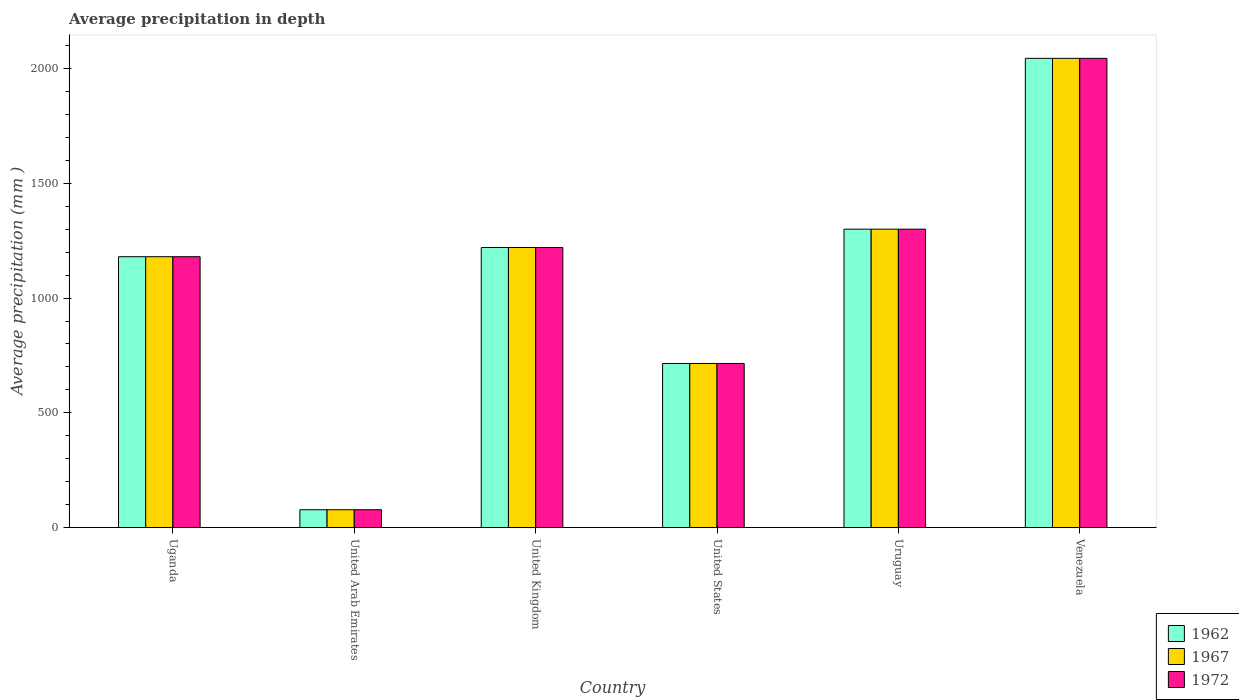How many different coloured bars are there?
Provide a succinct answer. 3. How many groups of bars are there?
Ensure brevity in your answer.  6. Are the number of bars per tick equal to the number of legend labels?
Make the answer very short. Yes. How many bars are there on the 3rd tick from the right?
Offer a terse response. 3. What is the label of the 6th group of bars from the left?
Offer a terse response. Venezuela. What is the average precipitation in 1972 in Venezuela?
Your answer should be very brief. 2044. Across all countries, what is the maximum average precipitation in 1972?
Provide a succinct answer. 2044. In which country was the average precipitation in 1962 maximum?
Your response must be concise. Venezuela. In which country was the average precipitation in 1962 minimum?
Your answer should be very brief. United Arab Emirates. What is the total average precipitation in 1972 in the graph?
Your answer should be compact. 6537. What is the difference between the average precipitation in 1967 in Uganda and that in Venezuela?
Provide a short and direct response. -864. What is the average average precipitation in 1962 per country?
Offer a terse response. 1089.5. What is the difference between the average precipitation of/in 1962 and average precipitation of/in 1967 in Uganda?
Offer a terse response. 0. What is the ratio of the average precipitation in 1972 in United Kingdom to that in United States?
Provide a succinct answer. 1.71. What is the difference between the highest and the second highest average precipitation in 1962?
Ensure brevity in your answer.  -824. What is the difference between the highest and the lowest average precipitation in 1967?
Your response must be concise. 1966. In how many countries, is the average precipitation in 1972 greater than the average average precipitation in 1972 taken over all countries?
Give a very brief answer. 4. Is the sum of the average precipitation in 1972 in United Kingdom and Uruguay greater than the maximum average precipitation in 1967 across all countries?
Your response must be concise. Yes. What does the 2nd bar from the left in Venezuela represents?
Your response must be concise. 1967. What does the 3rd bar from the right in United States represents?
Your answer should be compact. 1962. Are all the bars in the graph horizontal?
Keep it short and to the point. No. How many countries are there in the graph?
Make the answer very short. 6. What is the difference between two consecutive major ticks on the Y-axis?
Keep it short and to the point. 500. Are the values on the major ticks of Y-axis written in scientific E-notation?
Offer a very short reply. No. Does the graph contain grids?
Keep it short and to the point. No. Where does the legend appear in the graph?
Your answer should be compact. Bottom right. How many legend labels are there?
Keep it short and to the point. 3. How are the legend labels stacked?
Keep it short and to the point. Vertical. What is the title of the graph?
Provide a short and direct response. Average precipitation in depth. What is the label or title of the X-axis?
Keep it short and to the point. Country. What is the label or title of the Y-axis?
Keep it short and to the point. Average precipitation (mm ). What is the Average precipitation (mm ) of 1962 in Uganda?
Give a very brief answer. 1180. What is the Average precipitation (mm ) of 1967 in Uganda?
Make the answer very short. 1180. What is the Average precipitation (mm ) of 1972 in Uganda?
Ensure brevity in your answer.  1180. What is the Average precipitation (mm ) of 1962 in United Kingdom?
Give a very brief answer. 1220. What is the Average precipitation (mm ) in 1967 in United Kingdom?
Offer a very short reply. 1220. What is the Average precipitation (mm ) of 1972 in United Kingdom?
Give a very brief answer. 1220. What is the Average precipitation (mm ) in 1962 in United States?
Make the answer very short. 715. What is the Average precipitation (mm ) of 1967 in United States?
Give a very brief answer. 715. What is the Average precipitation (mm ) of 1972 in United States?
Keep it short and to the point. 715. What is the Average precipitation (mm ) in 1962 in Uruguay?
Offer a very short reply. 1300. What is the Average precipitation (mm ) in 1967 in Uruguay?
Make the answer very short. 1300. What is the Average precipitation (mm ) of 1972 in Uruguay?
Provide a short and direct response. 1300. What is the Average precipitation (mm ) in 1962 in Venezuela?
Provide a succinct answer. 2044. What is the Average precipitation (mm ) of 1967 in Venezuela?
Your response must be concise. 2044. What is the Average precipitation (mm ) in 1972 in Venezuela?
Ensure brevity in your answer.  2044. Across all countries, what is the maximum Average precipitation (mm ) of 1962?
Your answer should be very brief. 2044. Across all countries, what is the maximum Average precipitation (mm ) in 1967?
Your answer should be compact. 2044. Across all countries, what is the maximum Average precipitation (mm ) in 1972?
Offer a terse response. 2044. Across all countries, what is the minimum Average precipitation (mm ) of 1972?
Keep it short and to the point. 78. What is the total Average precipitation (mm ) of 1962 in the graph?
Ensure brevity in your answer.  6537. What is the total Average precipitation (mm ) in 1967 in the graph?
Provide a short and direct response. 6537. What is the total Average precipitation (mm ) in 1972 in the graph?
Your response must be concise. 6537. What is the difference between the Average precipitation (mm ) in 1962 in Uganda and that in United Arab Emirates?
Keep it short and to the point. 1102. What is the difference between the Average precipitation (mm ) in 1967 in Uganda and that in United Arab Emirates?
Your answer should be compact. 1102. What is the difference between the Average precipitation (mm ) of 1972 in Uganda and that in United Arab Emirates?
Keep it short and to the point. 1102. What is the difference between the Average precipitation (mm ) of 1972 in Uganda and that in United Kingdom?
Ensure brevity in your answer.  -40. What is the difference between the Average precipitation (mm ) in 1962 in Uganda and that in United States?
Your response must be concise. 465. What is the difference between the Average precipitation (mm ) in 1967 in Uganda and that in United States?
Offer a terse response. 465. What is the difference between the Average precipitation (mm ) of 1972 in Uganda and that in United States?
Make the answer very short. 465. What is the difference between the Average precipitation (mm ) in 1962 in Uganda and that in Uruguay?
Give a very brief answer. -120. What is the difference between the Average precipitation (mm ) in 1967 in Uganda and that in Uruguay?
Offer a very short reply. -120. What is the difference between the Average precipitation (mm ) of 1972 in Uganda and that in Uruguay?
Ensure brevity in your answer.  -120. What is the difference between the Average precipitation (mm ) of 1962 in Uganda and that in Venezuela?
Your answer should be compact. -864. What is the difference between the Average precipitation (mm ) of 1967 in Uganda and that in Venezuela?
Your response must be concise. -864. What is the difference between the Average precipitation (mm ) of 1972 in Uganda and that in Venezuela?
Make the answer very short. -864. What is the difference between the Average precipitation (mm ) in 1962 in United Arab Emirates and that in United Kingdom?
Offer a very short reply. -1142. What is the difference between the Average precipitation (mm ) of 1967 in United Arab Emirates and that in United Kingdom?
Provide a short and direct response. -1142. What is the difference between the Average precipitation (mm ) of 1972 in United Arab Emirates and that in United Kingdom?
Your answer should be compact. -1142. What is the difference between the Average precipitation (mm ) in 1962 in United Arab Emirates and that in United States?
Make the answer very short. -637. What is the difference between the Average precipitation (mm ) of 1967 in United Arab Emirates and that in United States?
Make the answer very short. -637. What is the difference between the Average precipitation (mm ) in 1972 in United Arab Emirates and that in United States?
Offer a very short reply. -637. What is the difference between the Average precipitation (mm ) in 1962 in United Arab Emirates and that in Uruguay?
Offer a terse response. -1222. What is the difference between the Average precipitation (mm ) of 1967 in United Arab Emirates and that in Uruguay?
Your answer should be compact. -1222. What is the difference between the Average precipitation (mm ) of 1972 in United Arab Emirates and that in Uruguay?
Offer a very short reply. -1222. What is the difference between the Average precipitation (mm ) of 1962 in United Arab Emirates and that in Venezuela?
Provide a succinct answer. -1966. What is the difference between the Average precipitation (mm ) in 1967 in United Arab Emirates and that in Venezuela?
Ensure brevity in your answer.  -1966. What is the difference between the Average precipitation (mm ) in 1972 in United Arab Emirates and that in Venezuela?
Your response must be concise. -1966. What is the difference between the Average precipitation (mm ) in 1962 in United Kingdom and that in United States?
Offer a very short reply. 505. What is the difference between the Average precipitation (mm ) of 1967 in United Kingdom and that in United States?
Give a very brief answer. 505. What is the difference between the Average precipitation (mm ) in 1972 in United Kingdom and that in United States?
Provide a succinct answer. 505. What is the difference between the Average precipitation (mm ) in 1962 in United Kingdom and that in Uruguay?
Make the answer very short. -80. What is the difference between the Average precipitation (mm ) of 1967 in United Kingdom and that in Uruguay?
Keep it short and to the point. -80. What is the difference between the Average precipitation (mm ) in 1972 in United Kingdom and that in Uruguay?
Keep it short and to the point. -80. What is the difference between the Average precipitation (mm ) of 1962 in United Kingdom and that in Venezuela?
Make the answer very short. -824. What is the difference between the Average precipitation (mm ) of 1967 in United Kingdom and that in Venezuela?
Ensure brevity in your answer.  -824. What is the difference between the Average precipitation (mm ) of 1972 in United Kingdom and that in Venezuela?
Offer a very short reply. -824. What is the difference between the Average precipitation (mm ) in 1962 in United States and that in Uruguay?
Give a very brief answer. -585. What is the difference between the Average precipitation (mm ) of 1967 in United States and that in Uruguay?
Offer a terse response. -585. What is the difference between the Average precipitation (mm ) of 1972 in United States and that in Uruguay?
Provide a succinct answer. -585. What is the difference between the Average precipitation (mm ) in 1962 in United States and that in Venezuela?
Your answer should be compact. -1329. What is the difference between the Average precipitation (mm ) in 1967 in United States and that in Venezuela?
Ensure brevity in your answer.  -1329. What is the difference between the Average precipitation (mm ) in 1972 in United States and that in Venezuela?
Give a very brief answer. -1329. What is the difference between the Average precipitation (mm ) in 1962 in Uruguay and that in Venezuela?
Provide a succinct answer. -744. What is the difference between the Average precipitation (mm ) of 1967 in Uruguay and that in Venezuela?
Make the answer very short. -744. What is the difference between the Average precipitation (mm ) of 1972 in Uruguay and that in Venezuela?
Ensure brevity in your answer.  -744. What is the difference between the Average precipitation (mm ) in 1962 in Uganda and the Average precipitation (mm ) in 1967 in United Arab Emirates?
Give a very brief answer. 1102. What is the difference between the Average precipitation (mm ) in 1962 in Uganda and the Average precipitation (mm ) in 1972 in United Arab Emirates?
Ensure brevity in your answer.  1102. What is the difference between the Average precipitation (mm ) in 1967 in Uganda and the Average precipitation (mm ) in 1972 in United Arab Emirates?
Offer a terse response. 1102. What is the difference between the Average precipitation (mm ) in 1962 in Uganda and the Average precipitation (mm ) in 1967 in United Kingdom?
Ensure brevity in your answer.  -40. What is the difference between the Average precipitation (mm ) of 1962 in Uganda and the Average precipitation (mm ) of 1967 in United States?
Your answer should be very brief. 465. What is the difference between the Average precipitation (mm ) of 1962 in Uganda and the Average precipitation (mm ) of 1972 in United States?
Ensure brevity in your answer.  465. What is the difference between the Average precipitation (mm ) in 1967 in Uganda and the Average precipitation (mm ) in 1972 in United States?
Offer a very short reply. 465. What is the difference between the Average precipitation (mm ) in 1962 in Uganda and the Average precipitation (mm ) in 1967 in Uruguay?
Your response must be concise. -120. What is the difference between the Average precipitation (mm ) of 1962 in Uganda and the Average precipitation (mm ) of 1972 in Uruguay?
Offer a terse response. -120. What is the difference between the Average precipitation (mm ) of 1967 in Uganda and the Average precipitation (mm ) of 1972 in Uruguay?
Your answer should be very brief. -120. What is the difference between the Average precipitation (mm ) of 1962 in Uganda and the Average precipitation (mm ) of 1967 in Venezuela?
Give a very brief answer. -864. What is the difference between the Average precipitation (mm ) in 1962 in Uganda and the Average precipitation (mm ) in 1972 in Venezuela?
Keep it short and to the point. -864. What is the difference between the Average precipitation (mm ) of 1967 in Uganda and the Average precipitation (mm ) of 1972 in Venezuela?
Provide a succinct answer. -864. What is the difference between the Average precipitation (mm ) in 1962 in United Arab Emirates and the Average precipitation (mm ) in 1967 in United Kingdom?
Your response must be concise. -1142. What is the difference between the Average precipitation (mm ) of 1962 in United Arab Emirates and the Average precipitation (mm ) of 1972 in United Kingdom?
Offer a very short reply. -1142. What is the difference between the Average precipitation (mm ) of 1967 in United Arab Emirates and the Average precipitation (mm ) of 1972 in United Kingdom?
Keep it short and to the point. -1142. What is the difference between the Average precipitation (mm ) of 1962 in United Arab Emirates and the Average precipitation (mm ) of 1967 in United States?
Your answer should be compact. -637. What is the difference between the Average precipitation (mm ) in 1962 in United Arab Emirates and the Average precipitation (mm ) in 1972 in United States?
Make the answer very short. -637. What is the difference between the Average precipitation (mm ) in 1967 in United Arab Emirates and the Average precipitation (mm ) in 1972 in United States?
Offer a very short reply. -637. What is the difference between the Average precipitation (mm ) in 1962 in United Arab Emirates and the Average precipitation (mm ) in 1967 in Uruguay?
Offer a terse response. -1222. What is the difference between the Average precipitation (mm ) in 1962 in United Arab Emirates and the Average precipitation (mm ) in 1972 in Uruguay?
Provide a succinct answer. -1222. What is the difference between the Average precipitation (mm ) of 1967 in United Arab Emirates and the Average precipitation (mm ) of 1972 in Uruguay?
Keep it short and to the point. -1222. What is the difference between the Average precipitation (mm ) of 1962 in United Arab Emirates and the Average precipitation (mm ) of 1967 in Venezuela?
Give a very brief answer. -1966. What is the difference between the Average precipitation (mm ) of 1962 in United Arab Emirates and the Average precipitation (mm ) of 1972 in Venezuela?
Your response must be concise. -1966. What is the difference between the Average precipitation (mm ) in 1967 in United Arab Emirates and the Average precipitation (mm ) in 1972 in Venezuela?
Give a very brief answer. -1966. What is the difference between the Average precipitation (mm ) of 1962 in United Kingdom and the Average precipitation (mm ) of 1967 in United States?
Your response must be concise. 505. What is the difference between the Average precipitation (mm ) of 1962 in United Kingdom and the Average precipitation (mm ) of 1972 in United States?
Your answer should be very brief. 505. What is the difference between the Average precipitation (mm ) of 1967 in United Kingdom and the Average precipitation (mm ) of 1972 in United States?
Your answer should be compact. 505. What is the difference between the Average precipitation (mm ) of 1962 in United Kingdom and the Average precipitation (mm ) of 1967 in Uruguay?
Make the answer very short. -80. What is the difference between the Average precipitation (mm ) in 1962 in United Kingdom and the Average precipitation (mm ) in 1972 in Uruguay?
Make the answer very short. -80. What is the difference between the Average precipitation (mm ) in 1967 in United Kingdom and the Average precipitation (mm ) in 1972 in Uruguay?
Keep it short and to the point. -80. What is the difference between the Average precipitation (mm ) in 1962 in United Kingdom and the Average precipitation (mm ) in 1967 in Venezuela?
Your answer should be compact. -824. What is the difference between the Average precipitation (mm ) in 1962 in United Kingdom and the Average precipitation (mm ) in 1972 in Venezuela?
Offer a terse response. -824. What is the difference between the Average precipitation (mm ) of 1967 in United Kingdom and the Average precipitation (mm ) of 1972 in Venezuela?
Your answer should be very brief. -824. What is the difference between the Average precipitation (mm ) in 1962 in United States and the Average precipitation (mm ) in 1967 in Uruguay?
Give a very brief answer. -585. What is the difference between the Average precipitation (mm ) of 1962 in United States and the Average precipitation (mm ) of 1972 in Uruguay?
Provide a short and direct response. -585. What is the difference between the Average precipitation (mm ) of 1967 in United States and the Average precipitation (mm ) of 1972 in Uruguay?
Give a very brief answer. -585. What is the difference between the Average precipitation (mm ) of 1962 in United States and the Average precipitation (mm ) of 1967 in Venezuela?
Give a very brief answer. -1329. What is the difference between the Average precipitation (mm ) in 1962 in United States and the Average precipitation (mm ) in 1972 in Venezuela?
Offer a terse response. -1329. What is the difference between the Average precipitation (mm ) in 1967 in United States and the Average precipitation (mm ) in 1972 in Venezuela?
Offer a very short reply. -1329. What is the difference between the Average precipitation (mm ) of 1962 in Uruguay and the Average precipitation (mm ) of 1967 in Venezuela?
Offer a very short reply. -744. What is the difference between the Average precipitation (mm ) of 1962 in Uruguay and the Average precipitation (mm ) of 1972 in Venezuela?
Your answer should be compact. -744. What is the difference between the Average precipitation (mm ) of 1967 in Uruguay and the Average precipitation (mm ) of 1972 in Venezuela?
Provide a succinct answer. -744. What is the average Average precipitation (mm ) of 1962 per country?
Offer a very short reply. 1089.5. What is the average Average precipitation (mm ) in 1967 per country?
Make the answer very short. 1089.5. What is the average Average precipitation (mm ) of 1972 per country?
Your answer should be compact. 1089.5. What is the difference between the Average precipitation (mm ) in 1962 and Average precipitation (mm ) in 1972 in Uganda?
Your response must be concise. 0. What is the difference between the Average precipitation (mm ) in 1962 and Average precipitation (mm ) in 1967 in United Arab Emirates?
Provide a succinct answer. 0. What is the difference between the Average precipitation (mm ) in 1967 and Average precipitation (mm ) in 1972 in United Arab Emirates?
Make the answer very short. 0. What is the difference between the Average precipitation (mm ) in 1962 and Average precipitation (mm ) in 1967 in United States?
Your answer should be very brief. 0. What is the difference between the Average precipitation (mm ) in 1962 and Average precipitation (mm ) in 1967 in Uruguay?
Your answer should be compact. 0. What is the difference between the Average precipitation (mm ) of 1967 and Average precipitation (mm ) of 1972 in Uruguay?
Provide a succinct answer. 0. What is the difference between the Average precipitation (mm ) in 1967 and Average precipitation (mm ) in 1972 in Venezuela?
Offer a terse response. 0. What is the ratio of the Average precipitation (mm ) of 1962 in Uganda to that in United Arab Emirates?
Provide a succinct answer. 15.13. What is the ratio of the Average precipitation (mm ) of 1967 in Uganda to that in United Arab Emirates?
Keep it short and to the point. 15.13. What is the ratio of the Average precipitation (mm ) in 1972 in Uganda to that in United Arab Emirates?
Your answer should be very brief. 15.13. What is the ratio of the Average precipitation (mm ) in 1962 in Uganda to that in United Kingdom?
Ensure brevity in your answer.  0.97. What is the ratio of the Average precipitation (mm ) in 1967 in Uganda to that in United Kingdom?
Ensure brevity in your answer.  0.97. What is the ratio of the Average precipitation (mm ) in 1972 in Uganda to that in United Kingdom?
Offer a terse response. 0.97. What is the ratio of the Average precipitation (mm ) in 1962 in Uganda to that in United States?
Ensure brevity in your answer.  1.65. What is the ratio of the Average precipitation (mm ) in 1967 in Uganda to that in United States?
Your answer should be very brief. 1.65. What is the ratio of the Average precipitation (mm ) in 1972 in Uganda to that in United States?
Your answer should be compact. 1.65. What is the ratio of the Average precipitation (mm ) in 1962 in Uganda to that in Uruguay?
Offer a terse response. 0.91. What is the ratio of the Average precipitation (mm ) of 1967 in Uganda to that in Uruguay?
Offer a terse response. 0.91. What is the ratio of the Average precipitation (mm ) of 1972 in Uganda to that in Uruguay?
Ensure brevity in your answer.  0.91. What is the ratio of the Average precipitation (mm ) in 1962 in Uganda to that in Venezuela?
Your answer should be compact. 0.58. What is the ratio of the Average precipitation (mm ) of 1967 in Uganda to that in Venezuela?
Provide a succinct answer. 0.58. What is the ratio of the Average precipitation (mm ) of 1972 in Uganda to that in Venezuela?
Provide a succinct answer. 0.58. What is the ratio of the Average precipitation (mm ) in 1962 in United Arab Emirates to that in United Kingdom?
Your response must be concise. 0.06. What is the ratio of the Average precipitation (mm ) of 1967 in United Arab Emirates to that in United Kingdom?
Keep it short and to the point. 0.06. What is the ratio of the Average precipitation (mm ) in 1972 in United Arab Emirates to that in United Kingdom?
Keep it short and to the point. 0.06. What is the ratio of the Average precipitation (mm ) in 1962 in United Arab Emirates to that in United States?
Offer a very short reply. 0.11. What is the ratio of the Average precipitation (mm ) of 1967 in United Arab Emirates to that in United States?
Offer a very short reply. 0.11. What is the ratio of the Average precipitation (mm ) in 1972 in United Arab Emirates to that in United States?
Provide a short and direct response. 0.11. What is the ratio of the Average precipitation (mm ) in 1962 in United Arab Emirates to that in Uruguay?
Provide a short and direct response. 0.06. What is the ratio of the Average precipitation (mm ) in 1972 in United Arab Emirates to that in Uruguay?
Keep it short and to the point. 0.06. What is the ratio of the Average precipitation (mm ) of 1962 in United Arab Emirates to that in Venezuela?
Provide a short and direct response. 0.04. What is the ratio of the Average precipitation (mm ) of 1967 in United Arab Emirates to that in Venezuela?
Offer a very short reply. 0.04. What is the ratio of the Average precipitation (mm ) of 1972 in United Arab Emirates to that in Venezuela?
Give a very brief answer. 0.04. What is the ratio of the Average precipitation (mm ) in 1962 in United Kingdom to that in United States?
Make the answer very short. 1.71. What is the ratio of the Average precipitation (mm ) of 1967 in United Kingdom to that in United States?
Keep it short and to the point. 1.71. What is the ratio of the Average precipitation (mm ) in 1972 in United Kingdom to that in United States?
Your answer should be compact. 1.71. What is the ratio of the Average precipitation (mm ) in 1962 in United Kingdom to that in Uruguay?
Your answer should be very brief. 0.94. What is the ratio of the Average precipitation (mm ) of 1967 in United Kingdom to that in Uruguay?
Offer a very short reply. 0.94. What is the ratio of the Average precipitation (mm ) of 1972 in United Kingdom to that in Uruguay?
Offer a very short reply. 0.94. What is the ratio of the Average precipitation (mm ) of 1962 in United Kingdom to that in Venezuela?
Make the answer very short. 0.6. What is the ratio of the Average precipitation (mm ) in 1967 in United Kingdom to that in Venezuela?
Provide a short and direct response. 0.6. What is the ratio of the Average precipitation (mm ) in 1972 in United Kingdom to that in Venezuela?
Provide a succinct answer. 0.6. What is the ratio of the Average precipitation (mm ) of 1962 in United States to that in Uruguay?
Your answer should be very brief. 0.55. What is the ratio of the Average precipitation (mm ) in 1967 in United States to that in Uruguay?
Keep it short and to the point. 0.55. What is the ratio of the Average precipitation (mm ) in 1972 in United States to that in Uruguay?
Make the answer very short. 0.55. What is the ratio of the Average precipitation (mm ) in 1962 in United States to that in Venezuela?
Provide a succinct answer. 0.35. What is the ratio of the Average precipitation (mm ) of 1967 in United States to that in Venezuela?
Keep it short and to the point. 0.35. What is the ratio of the Average precipitation (mm ) in 1972 in United States to that in Venezuela?
Keep it short and to the point. 0.35. What is the ratio of the Average precipitation (mm ) in 1962 in Uruguay to that in Venezuela?
Your response must be concise. 0.64. What is the ratio of the Average precipitation (mm ) of 1967 in Uruguay to that in Venezuela?
Give a very brief answer. 0.64. What is the ratio of the Average precipitation (mm ) of 1972 in Uruguay to that in Venezuela?
Your answer should be compact. 0.64. What is the difference between the highest and the second highest Average precipitation (mm ) in 1962?
Your response must be concise. 744. What is the difference between the highest and the second highest Average precipitation (mm ) of 1967?
Make the answer very short. 744. What is the difference between the highest and the second highest Average precipitation (mm ) in 1972?
Make the answer very short. 744. What is the difference between the highest and the lowest Average precipitation (mm ) in 1962?
Ensure brevity in your answer.  1966. What is the difference between the highest and the lowest Average precipitation (mm ) of 1967?
Your response must be concise. 1966. What is the difference between the highest and the lowest Average precipitation (mm ) of 1972?
Provide a succinct answer. 1966. 